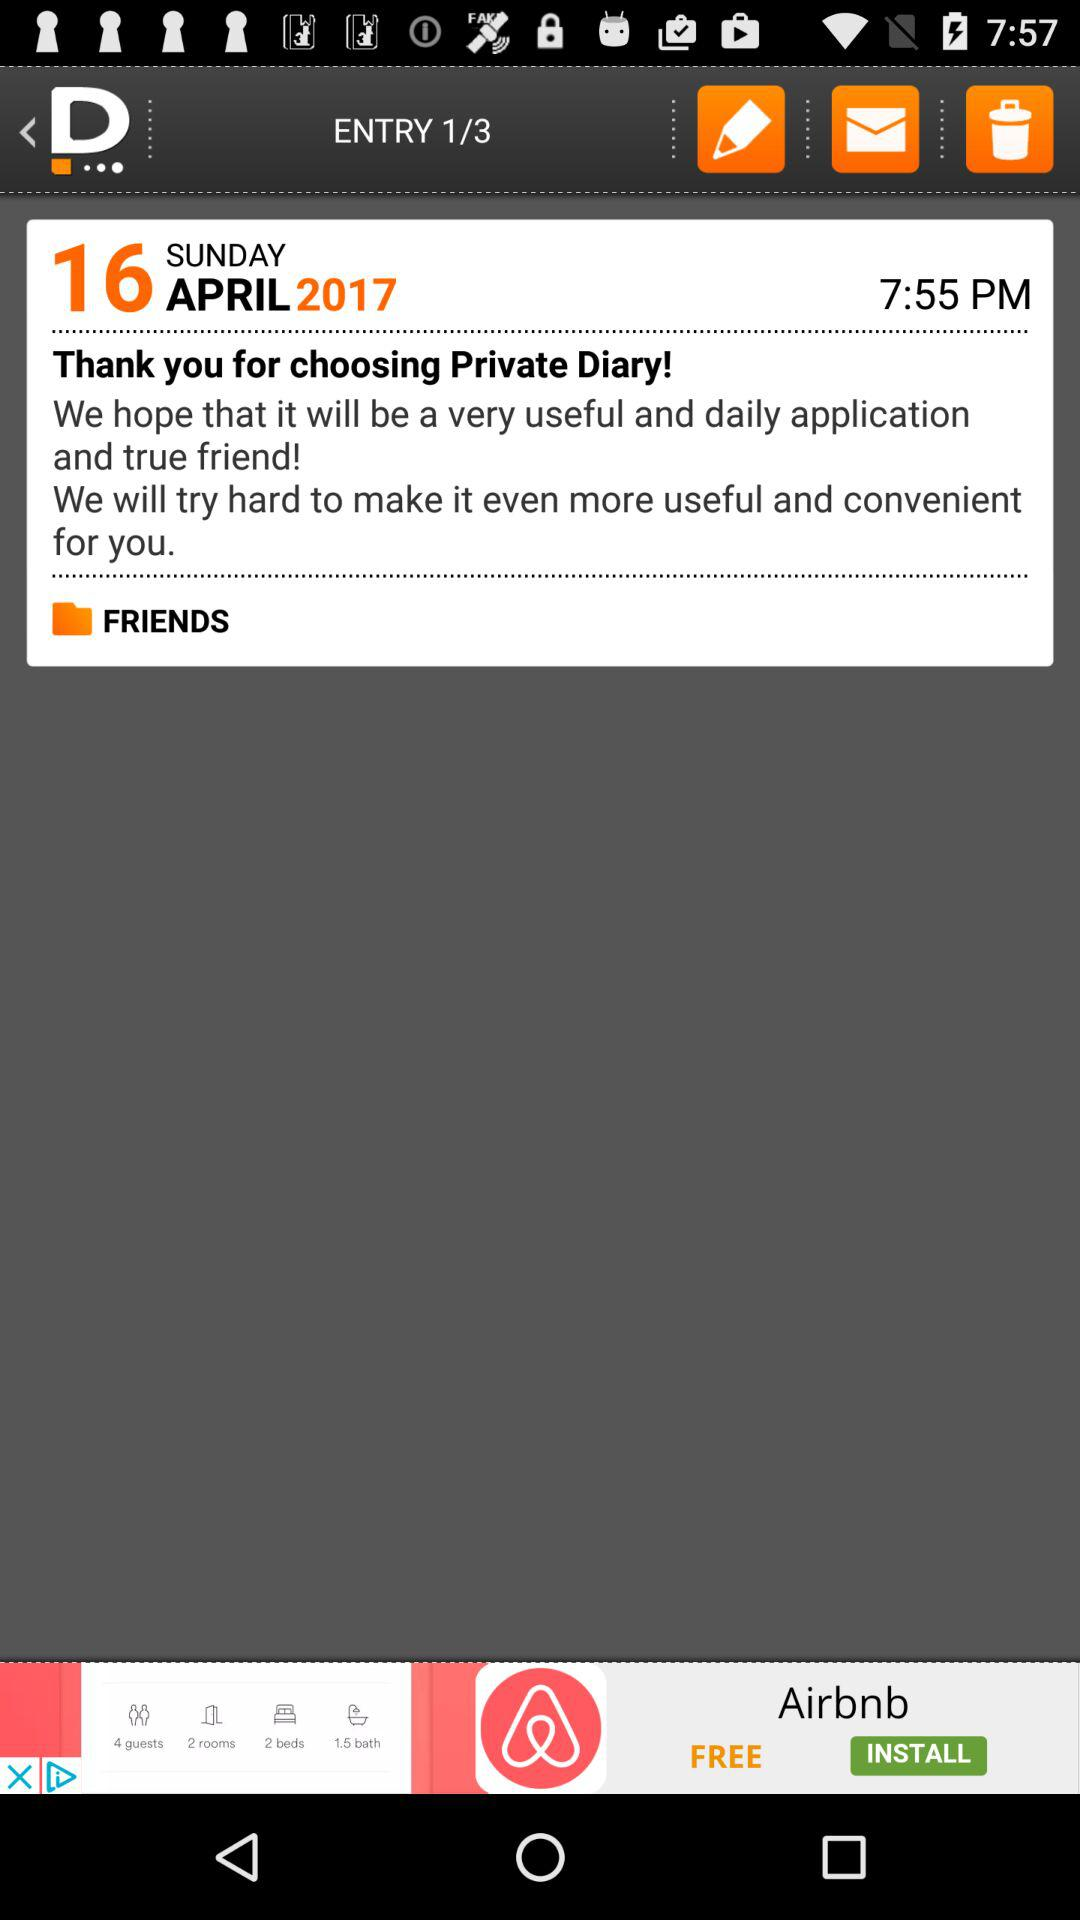What is the displayed time? The displayed time is 7:55 p.m. 